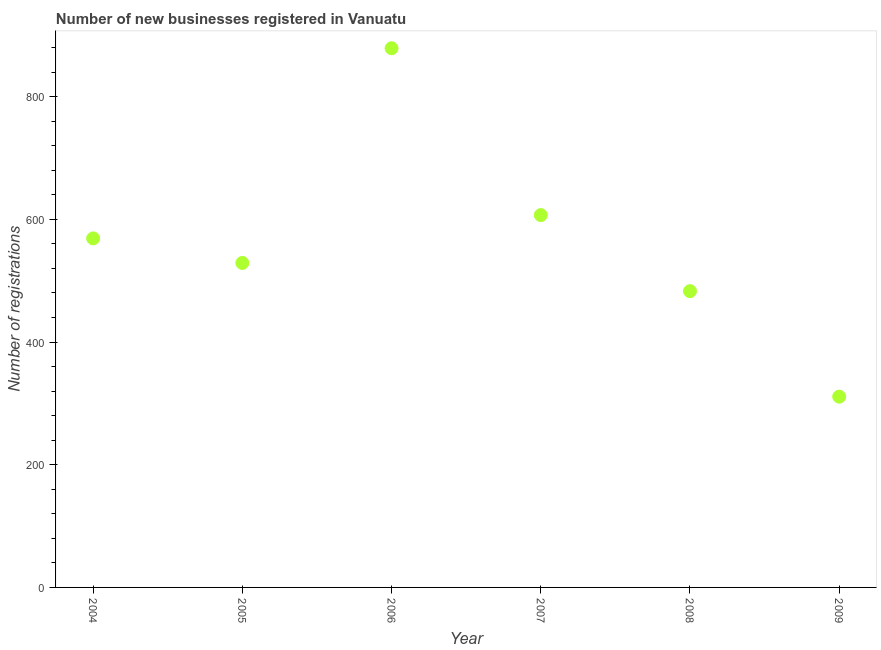What is the number of new business registrations in 2008?
Provide a short and direct response. 483. Across all years, what is the maximum number of new business registrations?
Provide a short and direct response. 879. Across all years, what is the minimum number of new business registrations?
Keep it short and to the point. 311. In which year was the number of new business registrations maximum?
Keep it short and to the point. 2006. What is the sum of the number of new business registrations?
Make the answer very short. 3378. What is the difference between the number of new business registrations in 2008 and 2009?
Ensure brevity in your answer.  172. What is the average number of new business registrations per year?
Ensure brevity in your answer.  563. What is the median number of new business registrations?
Make the answer very short. 549. What is the ratio of the number of new business registrations in 2005 to that in 2006?
Keep it short and to the point. 0.6. Is the difference between the number of new business registrations in 2004 and 2007 greater than the difference between any two years?
Provide a succinct answer. No. What is the difference between the highest and the second highest number of new business registrations?
Offer a very short reply. 272. What is the difference between the highest and the lowest number of new business registrations?
Give a very brief answer. 568. In how many years, is the number of new business registrations greater than the average number of new business registrations taken over all years?
Your answer should be compact. 3. What is the difference between two consecutive major ticks on the Y-axis?
Give a very brief answer. 200. Does the graph contain grids?
Your answer should be very brief. No. What is the title of the graph?
Offer a very short reply. Number of new businesses registered in Vanuatu. What is the label or title of the X-axis?
Keep it short and to the point. Year. What is the label or title of the Y-axis?
Your answer should be very brief. Number of registrations. What is the Number of registrations in 2004?
Keep it short and to the point. 569. What is the Number of registrations in 2005?
Your response must be concise. 529. What is the Number of registrations in 2006?
Provide a short and direct response. 879. What is the Number of registrations in 2007?
Give a very brief answer. 607. What is the Number of registrations in 2008?
Provide a short and direct response. 483. What is the Number of registrations in 2009?
Ensure brevity in your answer.  311. What is the difference between the Number of registrations in 2004 and 2005?
Provide a succinct answer. 40. What is the difference between the Number of registrations in 2004 and 2006?
Make the answer very short. -310. What is the difference between the Number of registrations in 2004 and 2007?
Give a very brief answer. -38. What is the difference between the Number of registrations in 2004 and 2009?
Make the answer very short. 258. What is the difference between the Number of registrations in 2005 and 2006?
Make the answer very short. -350. What is the difference between the Number of registrations in 2005 and 2007?
Your answer should be very brief. -78. What is the difference between the Number of registrations in 2005 and 2009?
Offer a very short reply. 218. What is the difference between the Number of registrations in 2006 and 2007?
Your answer should be very brief. 272. What is the difference between the Number of registrations in 2006 and 2008?
Your answer should be very brief. 396. What is the difference between the Number of registrations in 2006 and 2009?
Keep it short and to the point. 568. What is the difference between the Number of registrations in 2007 and 2008?
Your answer should be very brief. 124. What is the difference between the Number of registrations in 2007 and 2009?
Ensure brevity in your answer.  296. What is the difference between the Number of registrations in 2008 and 2009?
Offer a terse response. 172. What is the ratio of the Number of registrations in 2004 to that in 2005?
Provide a succinct answer. 1.08. What is the ratio of the Number of registrations in 2004 to that in 2006?
Make the answer very short. 0.65. What is the ratio of the Number of registrations in 2004 to that in 2007?
Your answer should be very brief. 0.94. What is the ratio of the Number of registrations in 2004 to that in 2008?
Offer a terse response. 1.18. What is the ratio of the Number of registrations in 2004 to that in 2009?
Offer a terse response. 1.83. What is the ratio of the Number of registrations in 2005 to that in 2006?
Offer a terse response. 0.6. What is the ratio of the Number of registrations in 2005 to that in 2007?
Keep it short and to the point. 0.87. What is the ratio of the Number of registrations in 2005 to that in 2008?
Provide a short and direct response. 1.09. What is the ratio of the Number of registrations in 2005 to that in 2009?
Provide a succinct answer. 1.7. What is the ratio of the Number of registrations in 2006 to that in 2007?
Offer a terse response. 1.45. What is the ratio of the Number of registrations in 2006 to that in 2008?
Your answer should be compact. 1.82. What is the ratio of the Number of registrations in 2006 to that in 2009?
Provide a short and direct response. 2.83. What is the ratio of the Number of registrations in 2007 to that in 2008?
Provide a short and direct response. 1.26. What is the ratio of the Number of registrations in 2007 to that in 2009?
Make the answer very short. 1.95. What is the ratio of the Number of registrations in 2008 to that in 2009?
Offer a very short reply. 1.55. 